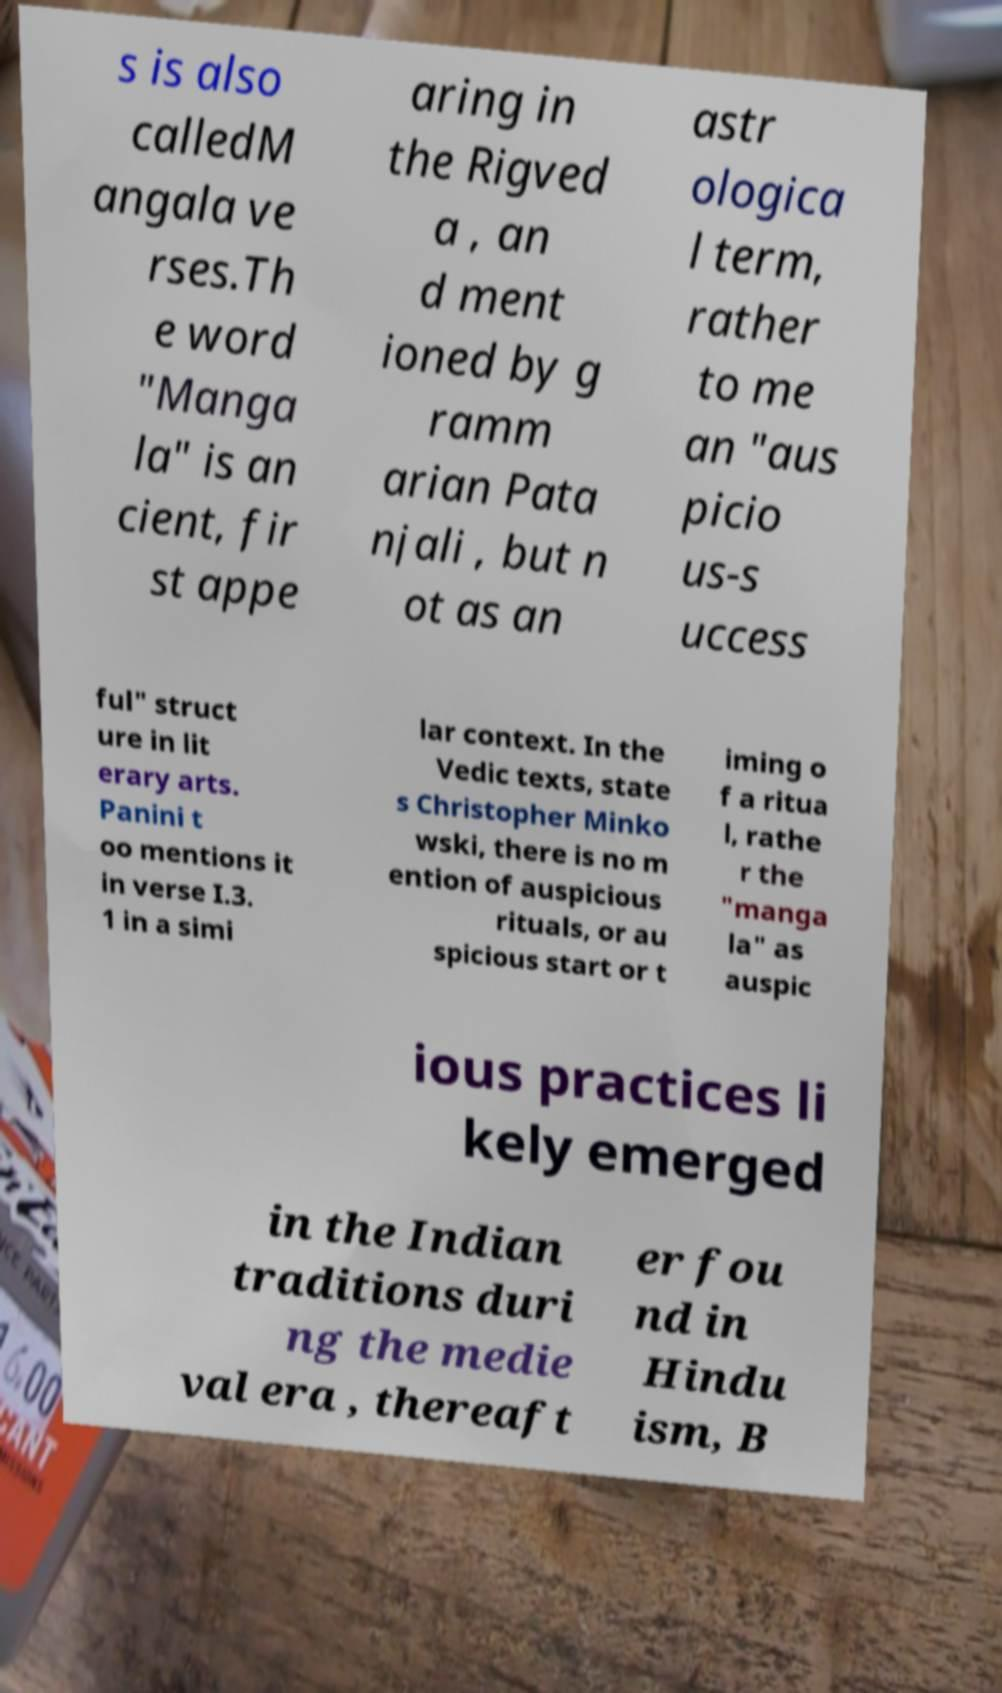Please read and relay the text visible in this image. What does it say? s is also calledM angala ve rses.Th e word "Manga la" is an cient, fir st appe aring in the Rigved a , an d ment ioned by g ramm arian Pata njali , but n ot as an astr ologica l term, rather to me an "aus picio us-s uccess ful" struct ure in lit erary arts. Panini t oo mentions it in verse I.3. 1 in a simi lar context. In the Vedic texts, state s Christopher Minko wski, there is no m ention of auspicious rituals, or au spicious start or t iming o f a ritua l, rathe r the "manga la" as auspic ious practices li kely emerged in the Indian traditions duri ng the medie val era , thereaft er fou nd in Hindu ism, B 